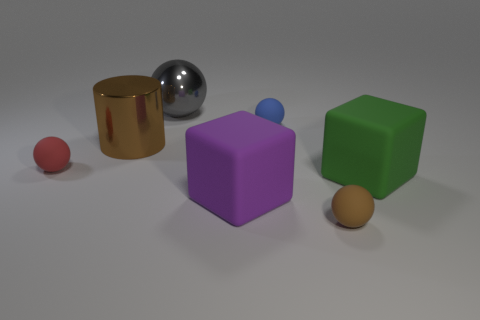Subtract all brown spheres. How many spheres are left? 3 Add 2 tiny green matte blocks. How many objects exist? 9 Subtract all green blocks. How many blocks are left? 1 Subtract all cylinders. How many objects are left? 6 Subtract all gray cubes. Subtract all large gray things. How many objects are left? 6 Add 5 large purple things. How many large purple things are left? 6 Add 7 large green shiny balls. How many large green shiny balls exist? 7 Subtract 0 gray cubes. How many objects are left? 7 Subtract 1 cubes. How many cubes are left? 1 Subtract all yellow cylinders. Subtract all green spheres. How many cylinders are left? 1 